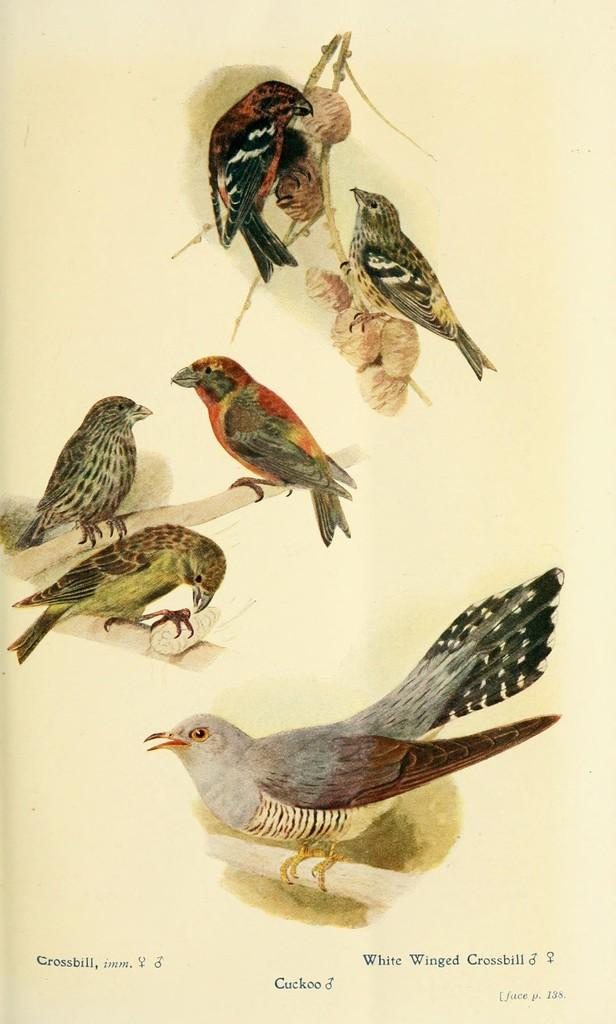What is featured on the poster in the image? The poster in the image includes birds. Can you describe the text at the bottom of the poster? Unfortunately, the provided facts do not give information about the text at the bottom of the poster. What is the color scheme of the poster? The provided facts do not give information about the color scheme of the poster. Can you tell me how many pears are depicted on the poster? There are no pears depicted on the poster; it features birds. What type of plane can be seen flying in the background of the poster? There is no plane present in the image or on the poster. 